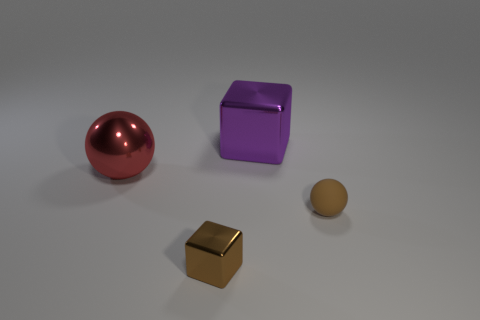Add 1 tiny brown objects. How many objects exist? 5 Add 4 big gray shiny cylinders. How many big gray shiny cylinders exist? 4 Subtract 0 purple cylinders. How many objects are left? 4 Subtract all shiny spheres. Subtract all big shiny objects. How many objects are left? 1 Add 3 big red metallic things. How many big red metallic things are left? 4 